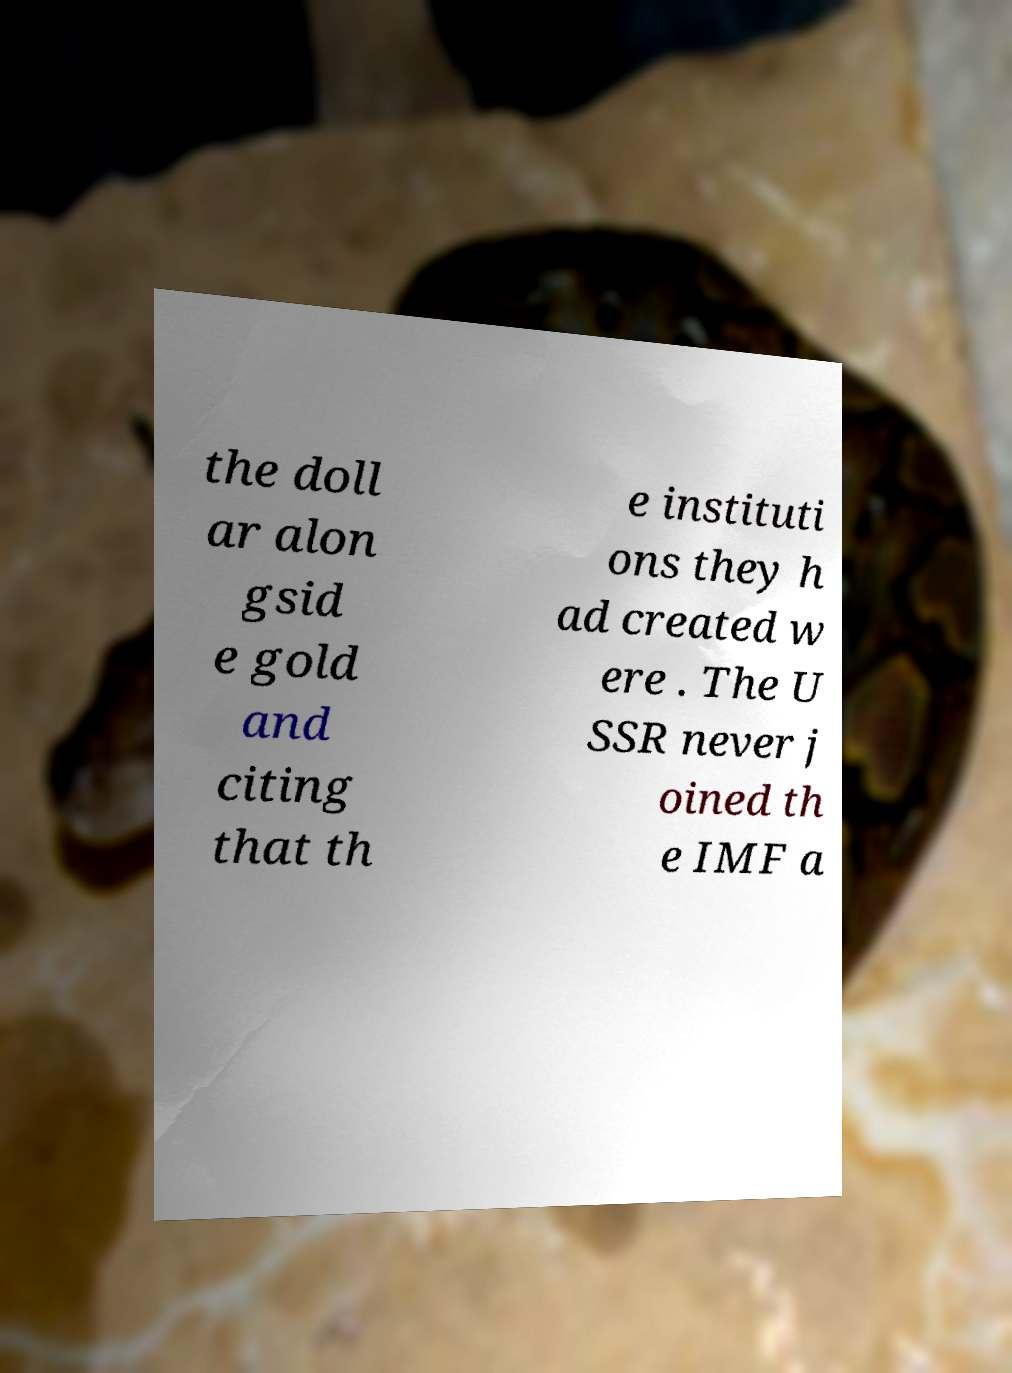For documentation purposes, I need the text within this image transcribed. Could you provide that? the doll ar alon gsid e gold and citing that th e instituti ons they h ad created w ere . The U SSR never j oined th e IMF a 